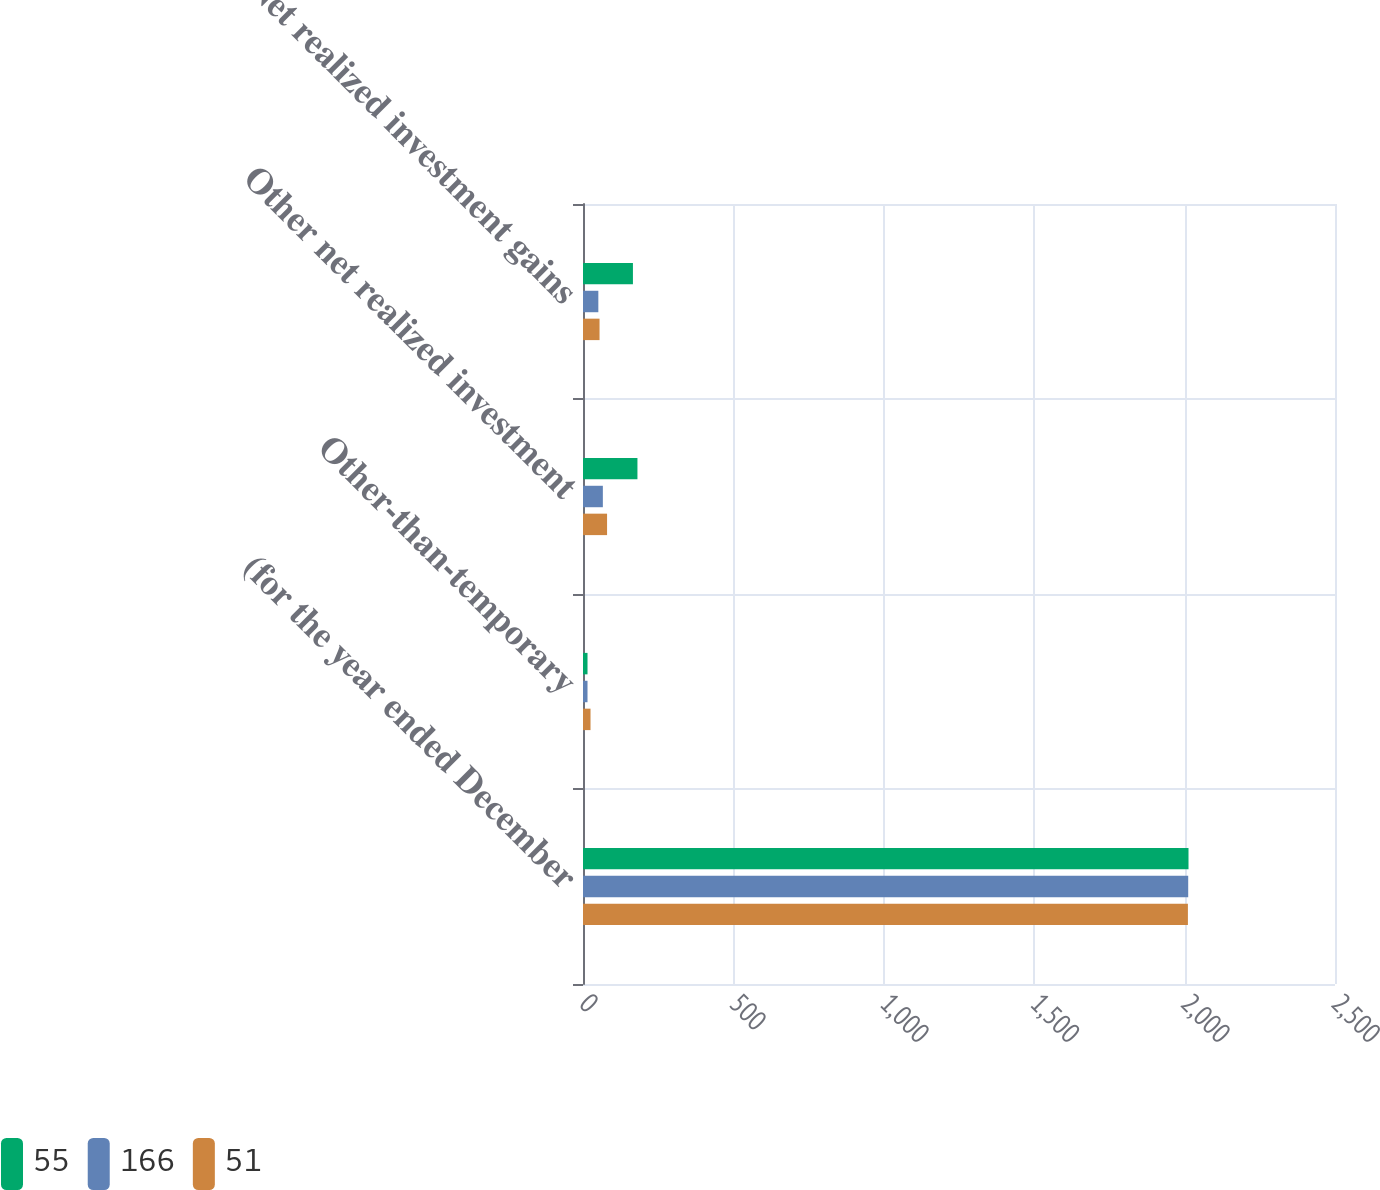Convert chart to OTSL. <chart><loc_0><loc_0><loc_500><loc_500><stacked_bar_chart><ecel><fcel>(for the year ended December<fcel>Other-than-temporary<fcel>Other net realized investment<fcel>Net realized investment gains<nl><fcel>55<fcel>2013<fcel>15<fcel>181<fcel>166<nl><fcel>166<fcel>2012<fcel>15<fcel>66<fcel>51<nl><fcel>51<fcel>2011<fcel>25<fcel>80<fcel>55<nl></chart> 